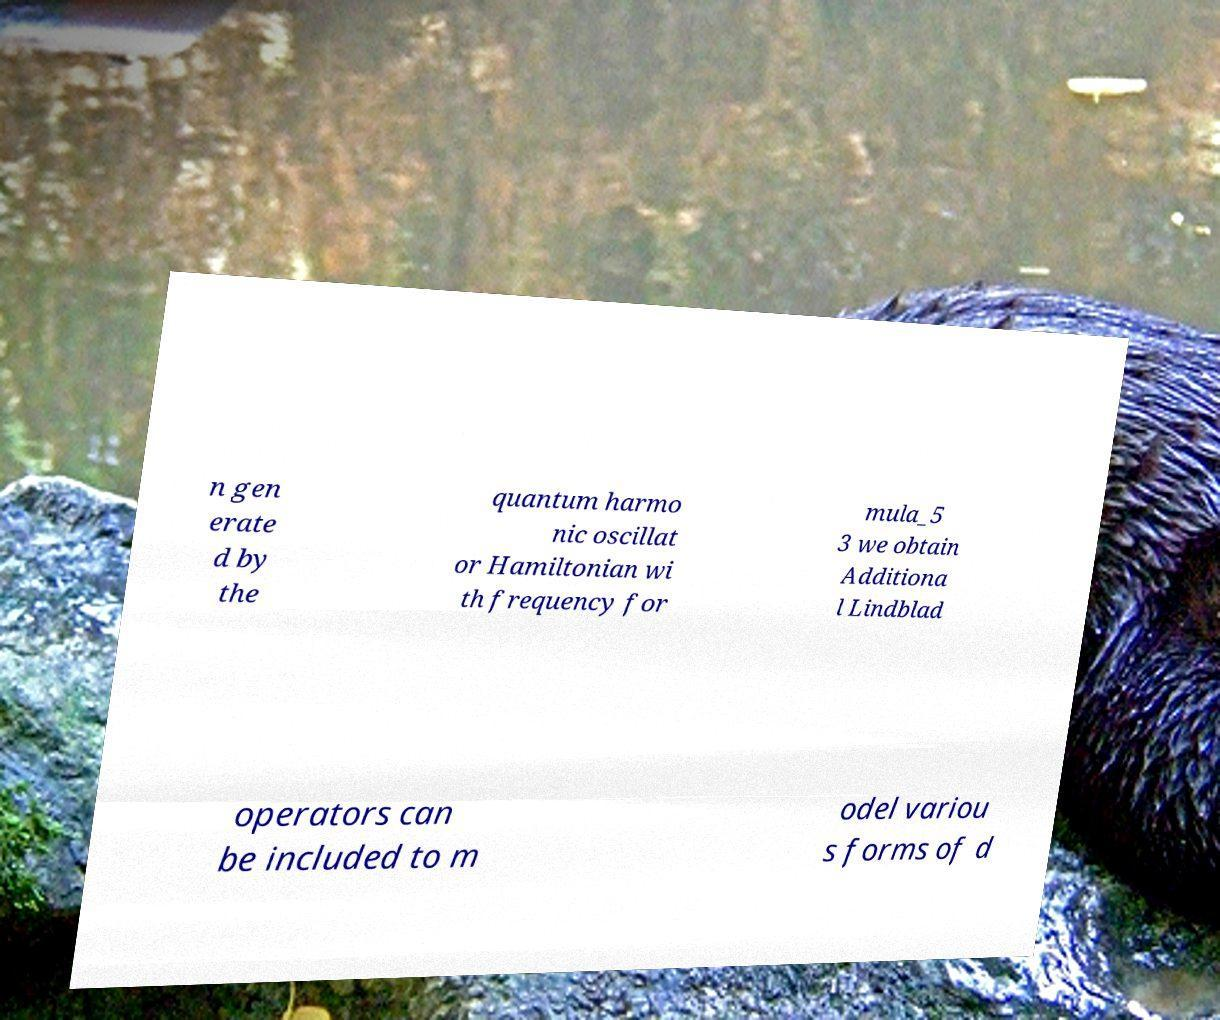Could you extract and type out the text from this image? n gen erate d by the quantum harmo nic oscillat or Hamiltonian wi th frequency for mula_5 3 we obtain Additiona l Lindblad operators can be included to m odel variou s forms of d 